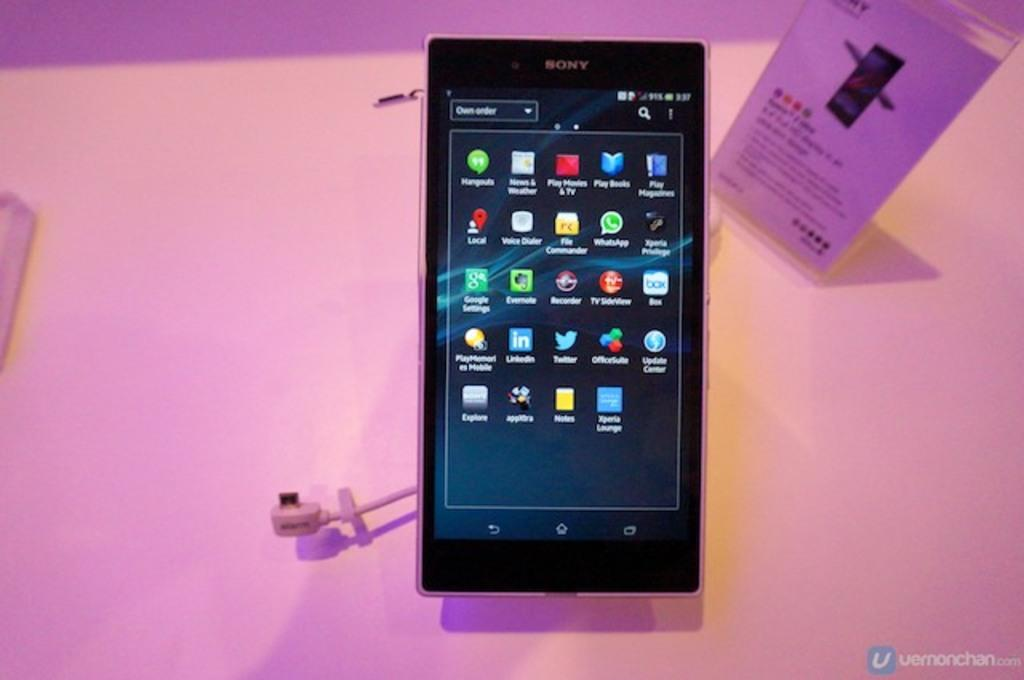<image>
Provide a brief description of the given image. A Sony cellphone placed on a white surface lit with purple light. 